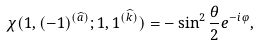<formula> <loc_0><loc_0><loc_500><loc_500>\chi ( 1 , ( - 1 ) ^ { ( \widehat { a } ) } ; 1 , 1 ^ { ( \widehat { k } ) } ) = - \sin ^ { 2 } \frac { \theta } { 2 } e ^ { - i \varphi } ,</formula> 